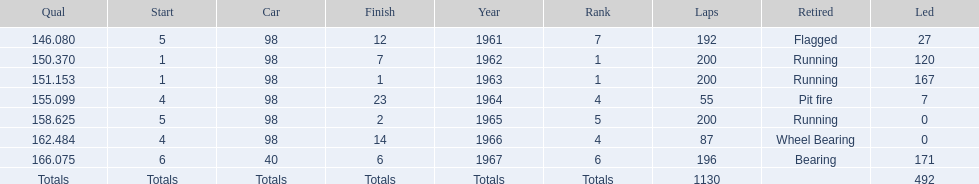What is the most common cause for a retired car? Running. 